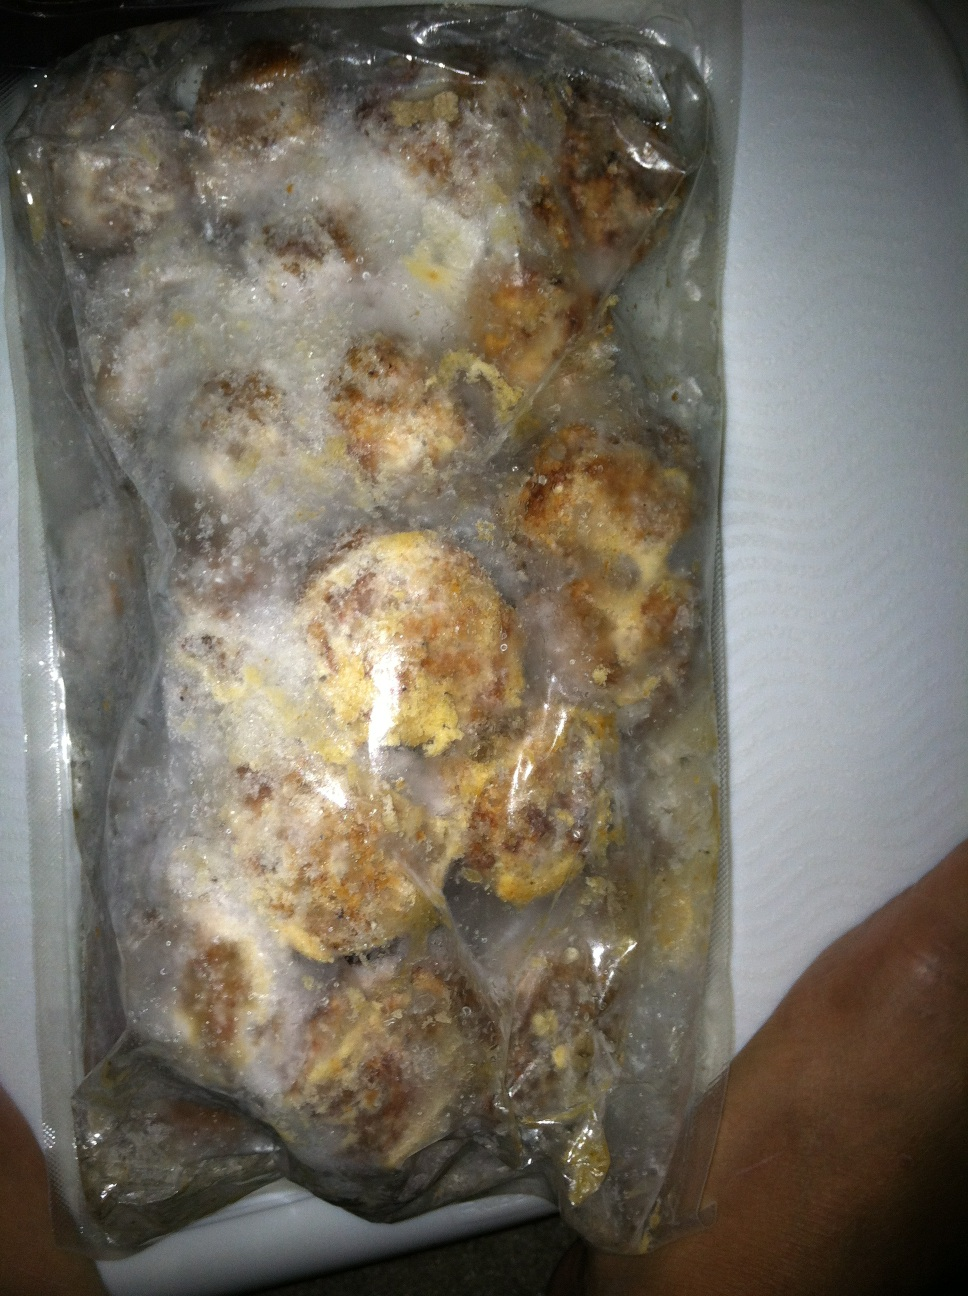What is this package? This is a package containing what seems to be frozen food, possibly meatballs based on its appearance. The food is covered in frost, indicating that it has been stored in a freezer. 